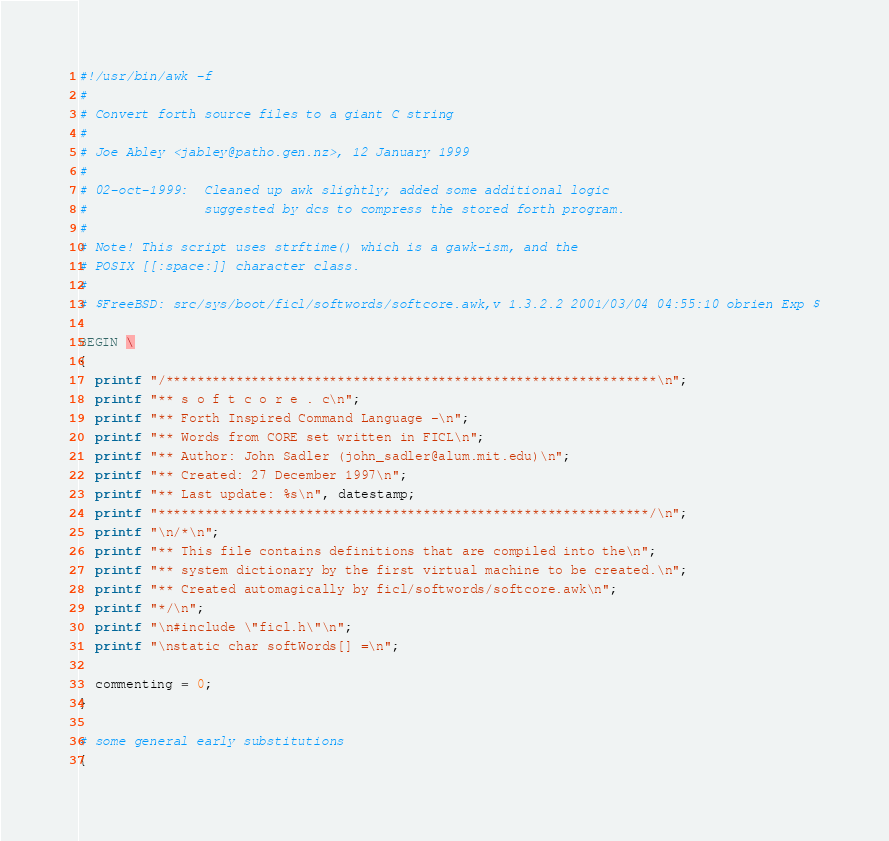Convert code to text. <code><loc_0><loc_0><loc_500><loc_500><_Awk_>#!/usr/bin/awk -f
#
# Convert forth source files to a giant C string
#
# Joe Abley <jabley@patho.gen.nz>, 12 January 1999
#
# 02-oct-1999:  Cleaned up awk slightly; added some additional logic
#               suggested by dcs to compress the stored forth program.
#
# Note! This script uses strftime() which is a gawk-ism, and the
# POSIX [[:space:]] character class.
#
# $FreeBSD: src/sys/boot/ficl/softwords/softcore.awk,v 1.3.2.2 2001/03/04 04:55:10 obrien Exp $

BEGIN \
{
  printf "/***************************************************************\n";
  printf "** s o f t c o r e . c\n";
  printf "** Forth Inspired Command Language -\n";
  printf "** Words from CORE set written in FICL\n";
  printf "** Author: John Sadler (john_sadler@alum.mit.edu)\n";
  printf "** Created: 27 December 1997\n";
  printf "** Last update: %s\n", datestamp;
  printf "***************************************************************/\n";
  printf "\n/*\n";
  printf "** This file contains definitions that are compiled into the\n";
  printf "** system dictionary by the first virtual machine to be created.\n";
  printf "** Created automagically by ficl/softwords/softcore.awk\n";
  printf "*/\n";
  printf "\n#include \"ficl.h\"\n";
  printf "\nstatic char softWords[] =\n";

  commenting = 0;
}

# some general early substitutions
{</code> 